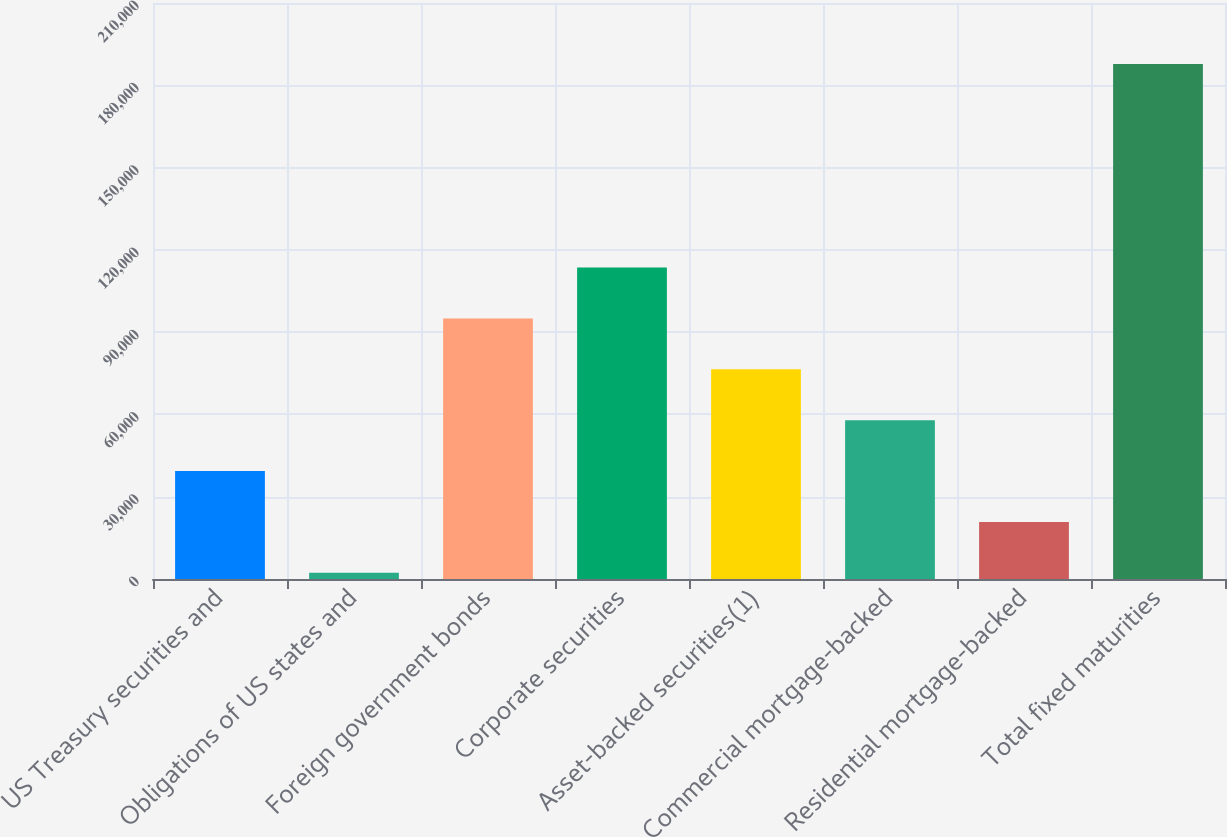<chart> <loc_0><loc_0><loc_500><loc_500><bar_chart><fcel>US Treasury securities and<fcel>Obligations of US states and<fcel>Foreign government bonds<fcel>Corporate securities<fcel>Asset-backed securities(1)<fcel>Commercial mortgage-backed<fcel>Residential mortgage-backed<fcel>Total fixed maturities<nl><fcel>39354<fcel>2254<fcel>95004<fcel>113554<fcel>76454<fcel>57904<fcel>20804<fcel>187754<nl></chart> 